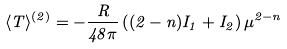Convert formula to latex. <formula><loc_0><loc_0><loc_500><loc_500>\langle T \rangle ^ { ( 2 ) } = - \frac { R } { 4 8 \pi } \left ( ( 2 - n ) I _ { 1 } + I _ { 2 } \right ) \mu ^ { 2 - n }</formula> 